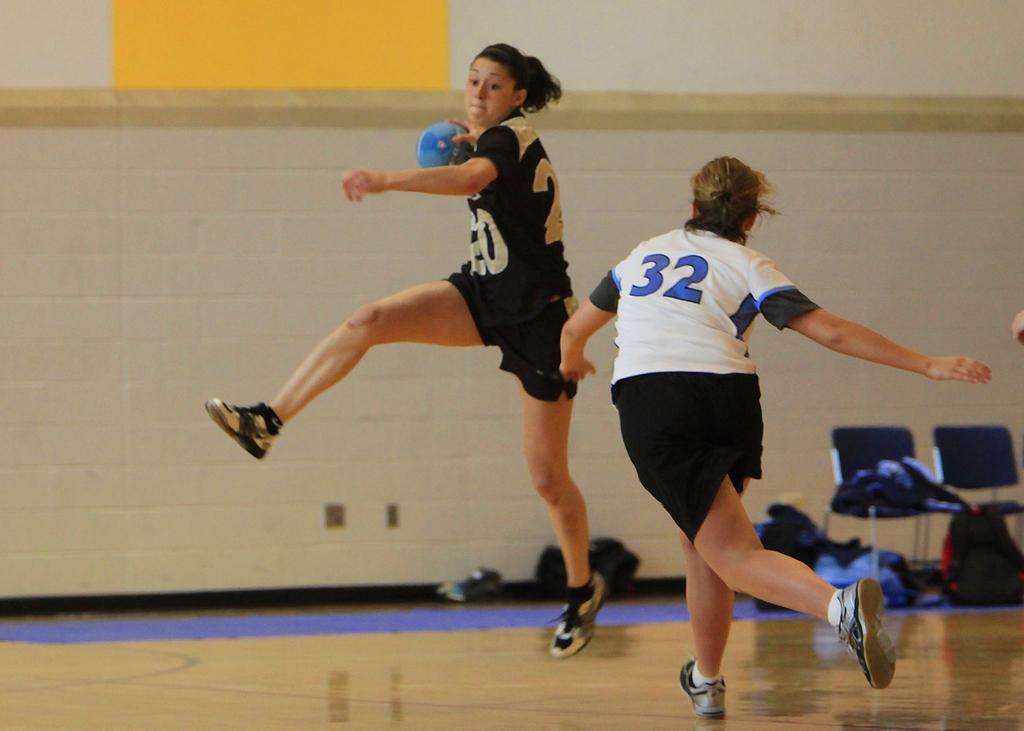Can you describe this image briefly? In this image, there is a floor, there are two women playing a game, at the background there are some chairs and there are some bags, there is a wall. 